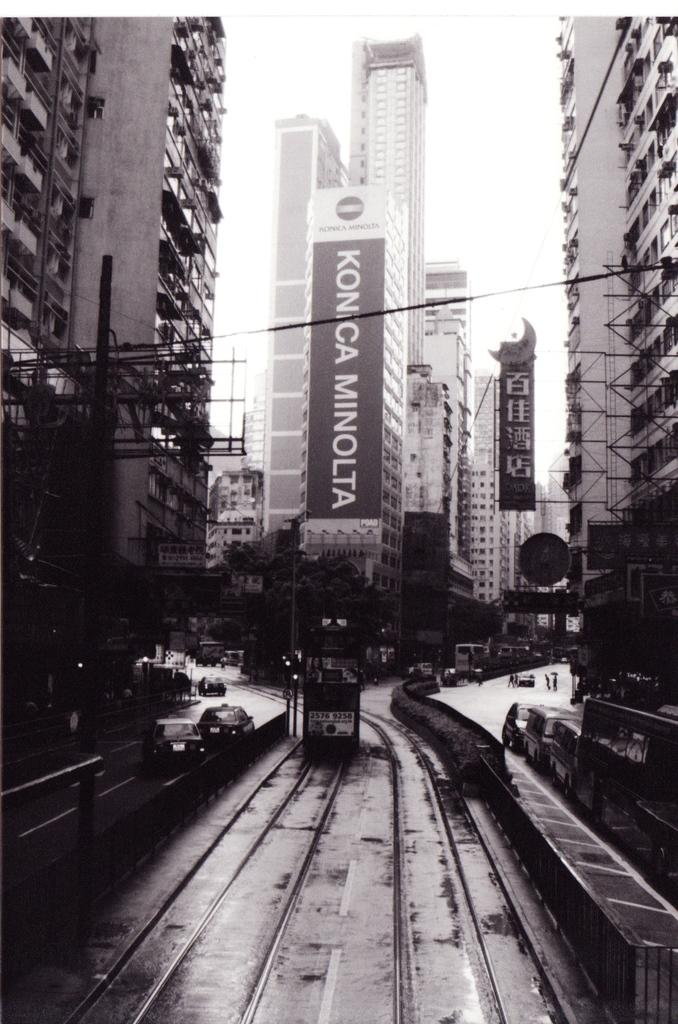Provide a one-sentence caption for the provided image. Big black and white Konica Minolta sign on a building. 